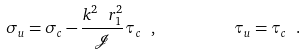<formula> <loc_0><loc_0><loc_500><loc_500>\sigma _ { u } = \sigma _ { c } - \frac { k ^ { 2 } \ r _ { 1 } ^ { 2 } } { \mathcal { J } } \tau _ { c } \ , \quad \ \quad \tau _ { u } = \tau _ { c } \ .</formula> 